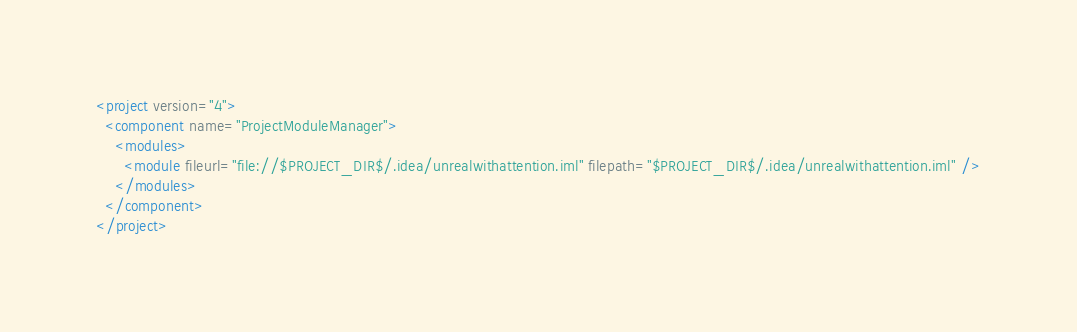Convert code to text. <code><loc_0><loc_0><loc_500><loc_500><_XML_><project version="4">
  <component name="ProjectModuleManager">
    <modules>
      <module fileurl="file://$PROJECT_DIR$/.idea/unrealwithattention.iml" filepath="$PROJECT_DIR$/.idea/unrealwithattention.iml" />
    </modules>
  </component>
</project></code> 